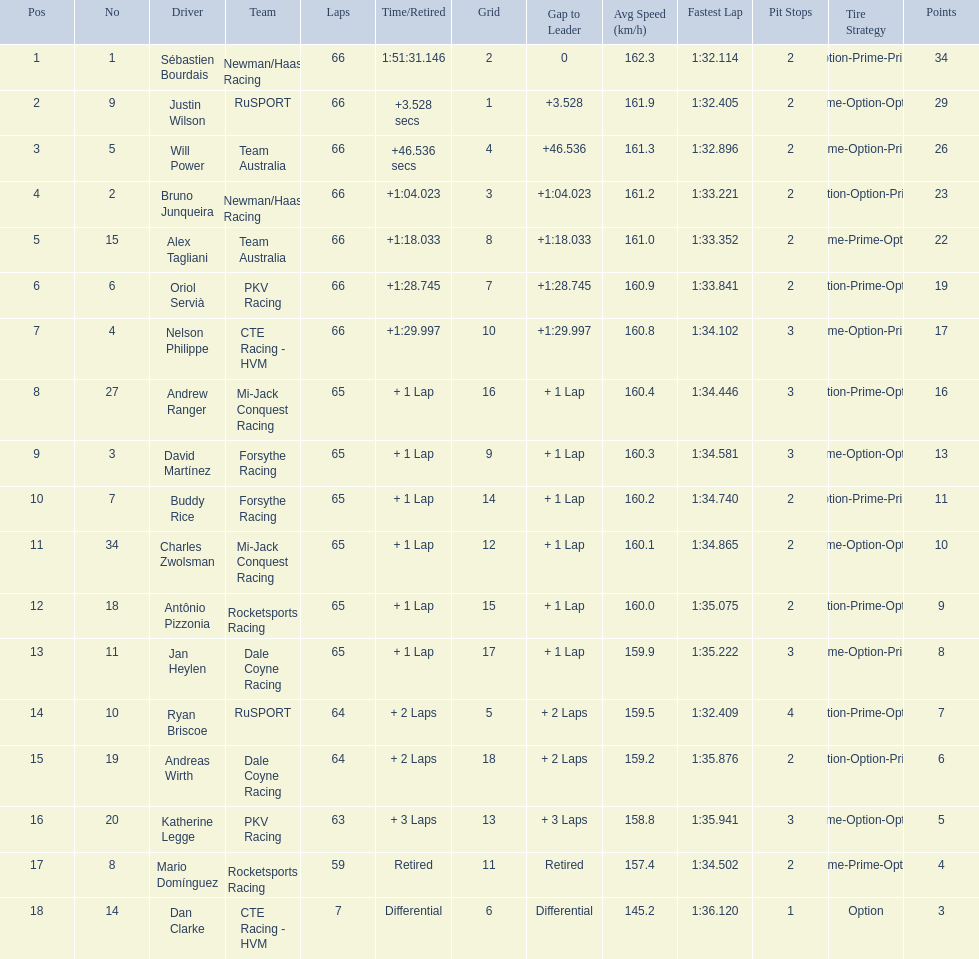Rice finished 10th. who finished next? Charles Zwolsman. 